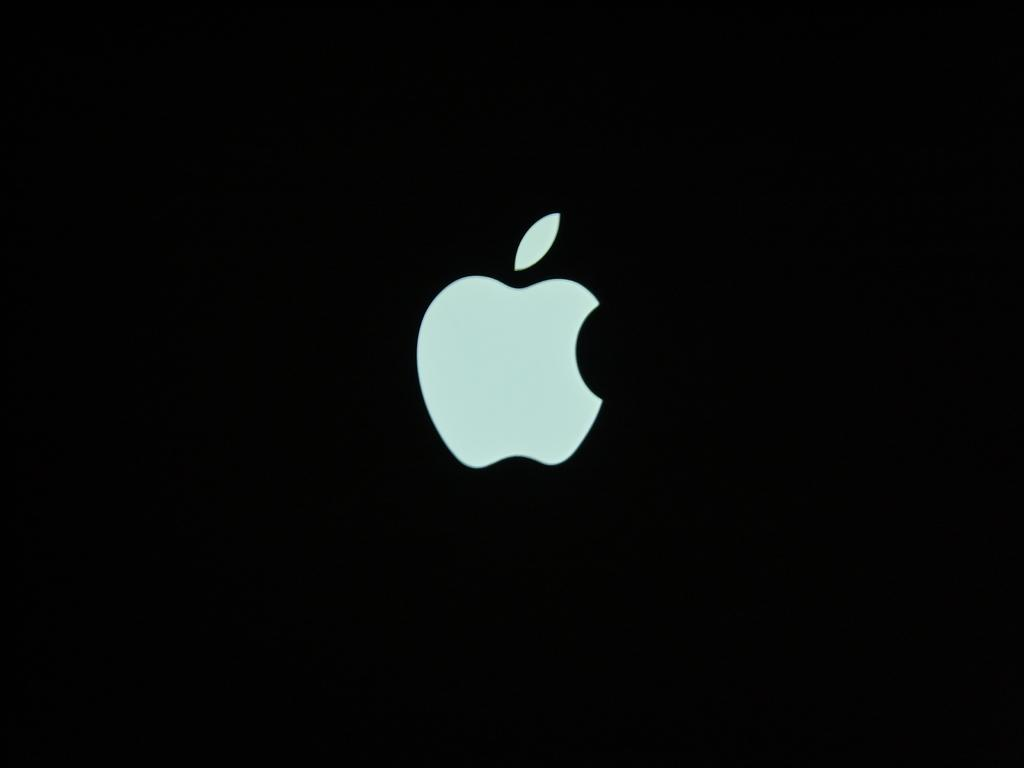What is the main feature in the center of the image? There is an apple logo in the center of the image. What is the color of the background in the image? The background of the image is dark. What type of juice is being served at the school fair in the image? There is no school fair or juice present in the image; it only features an apple logo on a dark background. Are there any fairies visible in the image? There are no fairies present in the image; it only features an apple logo on a dark background. 